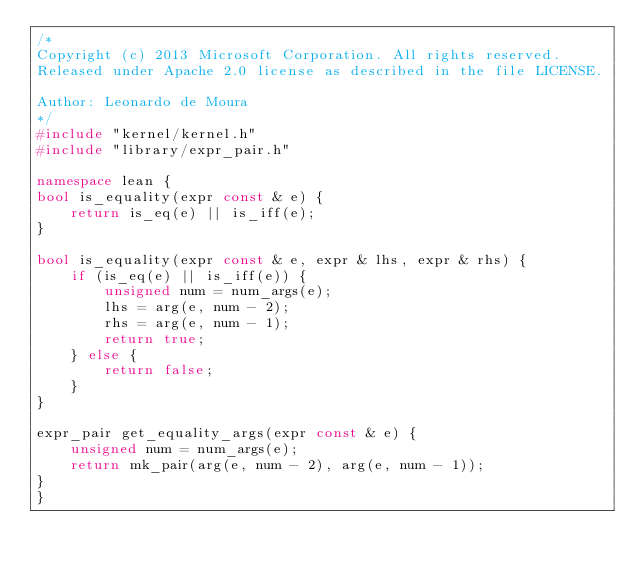Convert code to text. <code><loc_0><loc_0><loc_500><loc_500><_C++_>/*
Copyright (c) 2013 Microsoft Corporation. All rights reserved.
Released under Apache 2.0 license as described in the file LICENSE.

Author: Leonardo de Moura
*/
#include "kernel/kernel.h"
#include "library/expr_pair.h"

namespace lean {
bool is_equality(expr const & e) {
    return is_eq(e) || is_iff(e);
}

bool is_equality(expr const & e, expr & lhs, expr & rhs) {
    if (is_eq(e) || is_iff(e)) {
        unsigned num = num_args(e);
        lhs = arg(e, num - 2);
        rhs = arg(e, num - 1);
        return true;
    } else {
        return false;
    }
}

expr_pair get_equality_args(expr const & e) {
    unsigned num = num_args(e);
    return mk_pair(arg(e, num - 2), arg(e, num - 1));
}
}
</code> 